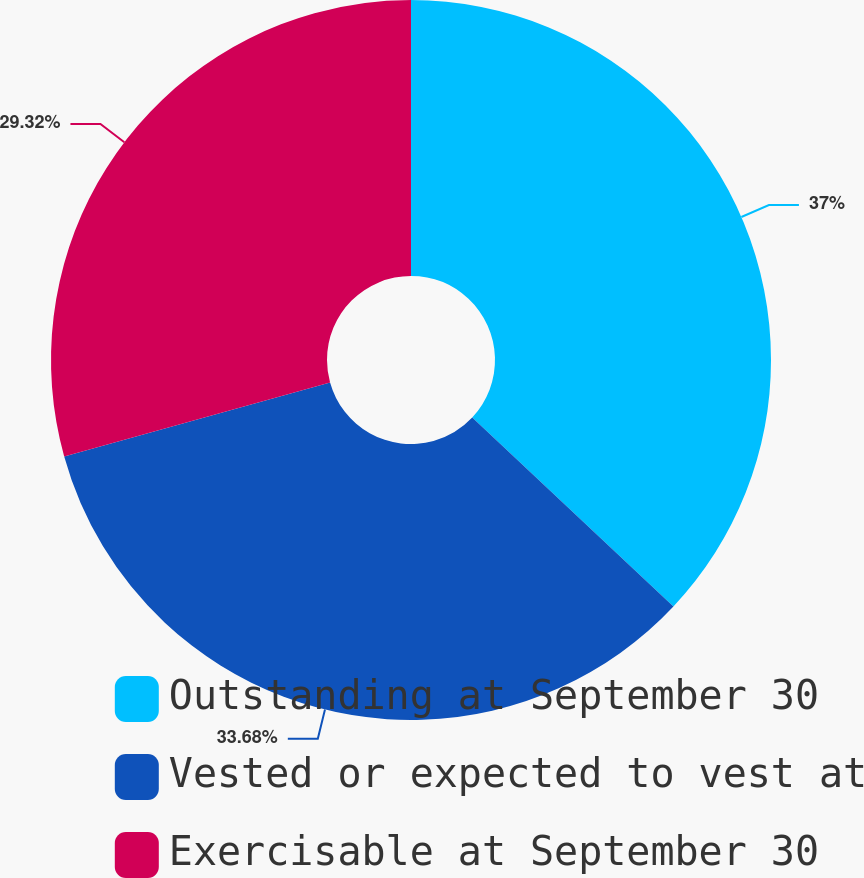Convert chart to OTSL. <chart><loc_0><loc_0><loc_500><loc_500><pie_chart><fcel>Outstanding at September 30<fcel>Vested or expected to vest at<fcel>Exercisable at September 30<nl><fcel>37.0%<fcel>33.68%<fcel>29.32%<nl></chart> 